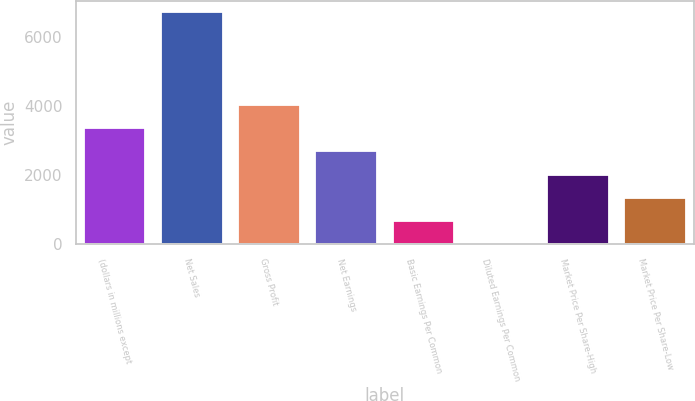Convert chart. <chart><loc_0><loc_0><loc_500><loc_500><bar_chart><fcel>(dollars in millions except<fcel>Net Sales<fcel>Gross Profit<fcel>Net Earnings<fcel>Basic Earnings Per Common<fcel>Diluted Earnings Per Common<fcel>Market Price Per Share-High<fcel>Market Price Per Share-Low<nl><fcel>3359.67<fcel>6718.4<fcel>4031.42<fcel>2687.92<fcel>672.67<fcel>0.92<fcel>2016.17<fcel>1344.42<nl></chart> 